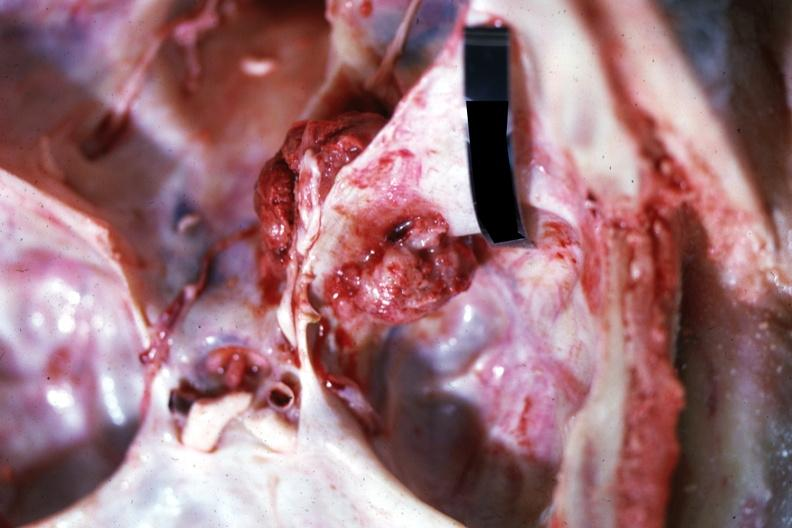what is present?
Answer the question using a single word or phrase. Metastatic carcinoma 